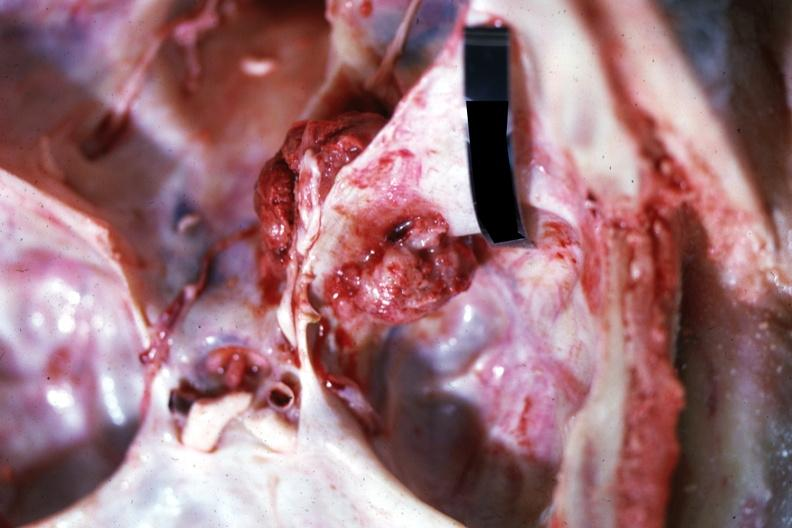what is present?
Answer the question using a single word or phrase. Metastatic carcinoma 